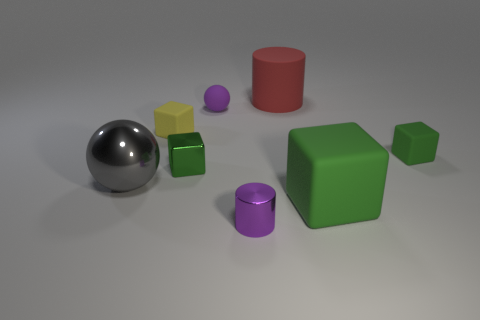How many green blocks must be subtracted to get 1 green blocks? 2 Subtract all red cylinders. How many green blocks are left? 3 Add 2 tiny gray metallic objects. How many objects exist? 10 Subtract all balls. How many objects are left? 6 Subtract 0 blue cubes. How many objects are left? 8 Subtract all large red objects. Subtract all tiny green matte cylinders. How many objects are left? 7 Add 2 small matte balls. How many small matte balls are left? 3 Add 5 gray matte cubes. How many gray matte cubes exist? 5 